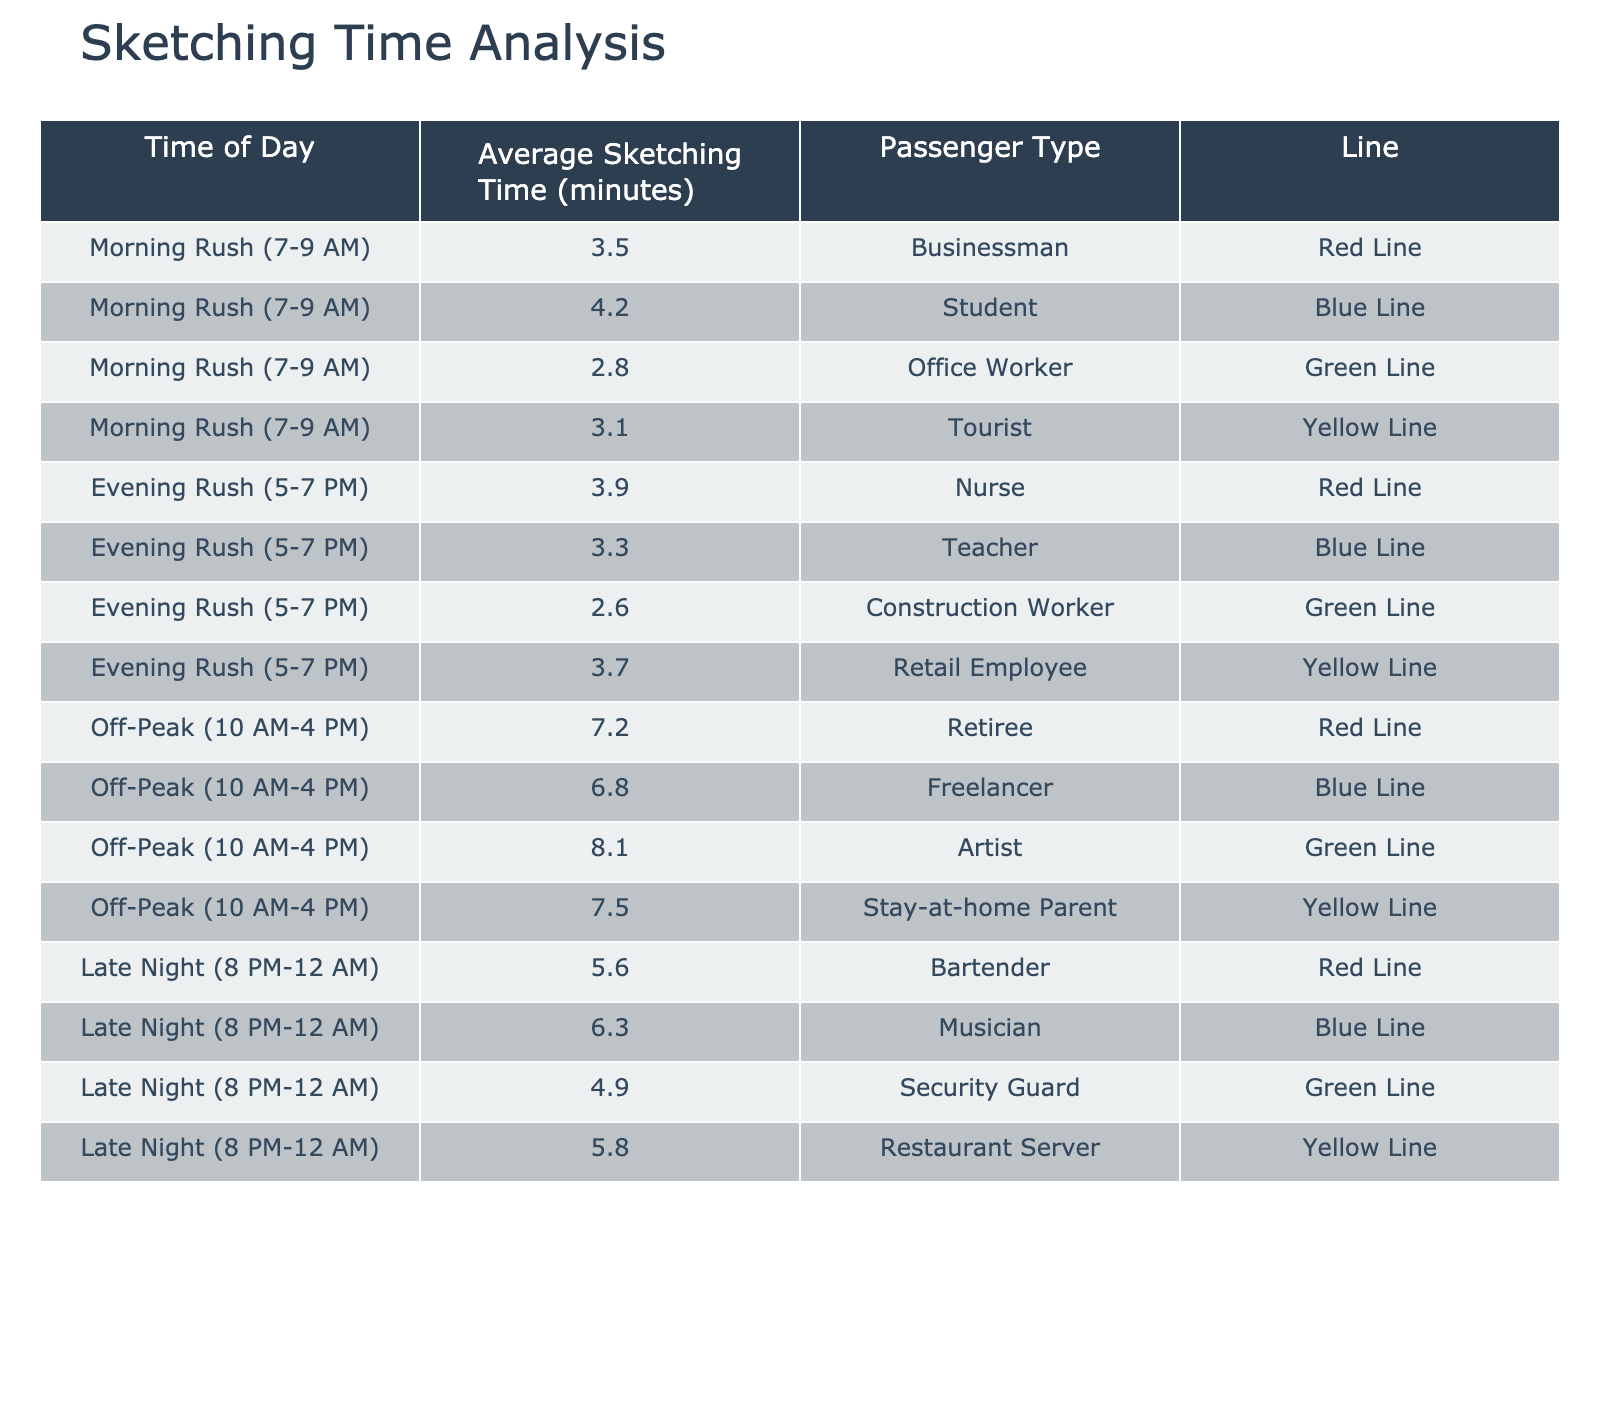What's the average sketching time for a businessman during morning rush hours? From the table, the average sketching time for the businessman during morning rush hours is directly listed as 3.5 minutes.
Answer: 3.5 minutes What is the average sketching time for passengers during off-peak hours? To find the average off-peak sketching time, we total the values for all passenger types during off-peak hours: (7.2 + 6.8 + 8.1 + 7.5) = 29.6 minutes. There are 4 passenger types, so we divide 29.6 by 4, which results in 7.4 minutes.
Answer: 7.4 minutes Is the average sketching time for a nurse longer than that for a teacher during the evening rush? The average sketching time for a nurse is 3.9 minutes, while for a teacher, it is 3.3 minutes. Since 3.9 is greater than 3.3, the answer is yes.
Answer: Yes Which passenger type has the longest average sketching time during off-peak hours? In the off-peak hours data, the average sketching times are: retiree (7.2), freelancer (6.8), artist (8.1), and stay-at-home parent (7.5). The artist has the longest average time at 8.1 minutes.
Answer: Artist What is the difference in average sketching time between a tourist during morning rush hours and a musician during late night? The average sketching time for a tourist is 3.1 minutes, while for a musician, it is 6.3 minutes. The difference is calculated as 6.3 - 3.1 = 3.2 minutes.
Answer: 3.2 minutes During which time category is the average sketching time highest, and what is that average compared to the lowest time? Analyzing the table, the averages are: Morning Rush (3.5), Evening Rush (3.8), Off-Peak (7.4), and Late Night (5.4). The highest is Off-Peak with 7.4 minutes and the lowest is Morning Rush with 3.5 minutes. The difference is 7.4 - 3.5 = 3.9 minutes.
Answer: 3.9 minutes How many different passenger types are sketched during the evening rush hours, and who has the shortest average time? There are 4 passenger types sketched during the evening rush: nurse, teacher, construction worker, and retail employee. The average sketching times are: 3.9 for nurse, 3.3 for teacher, 2.6 for construction worker, and 3.7 for retail employee. The shortest average time is for the construction worker at 2.6 minutes.
Answer: 4 and construction worker What is the total average sketching time for all passenger types during morning rush hours? The average sketching times during morning rush are: businessman (3.5), student (4.2), office worker (2.8), and tourist (3.1). Adding these values gives 3.5 + 4.2 + 2.8 + 3.1 = 13.6 minutes. There are 4 types, so the total time is 13.6 minutes.
Answer: 13.6 minutes 